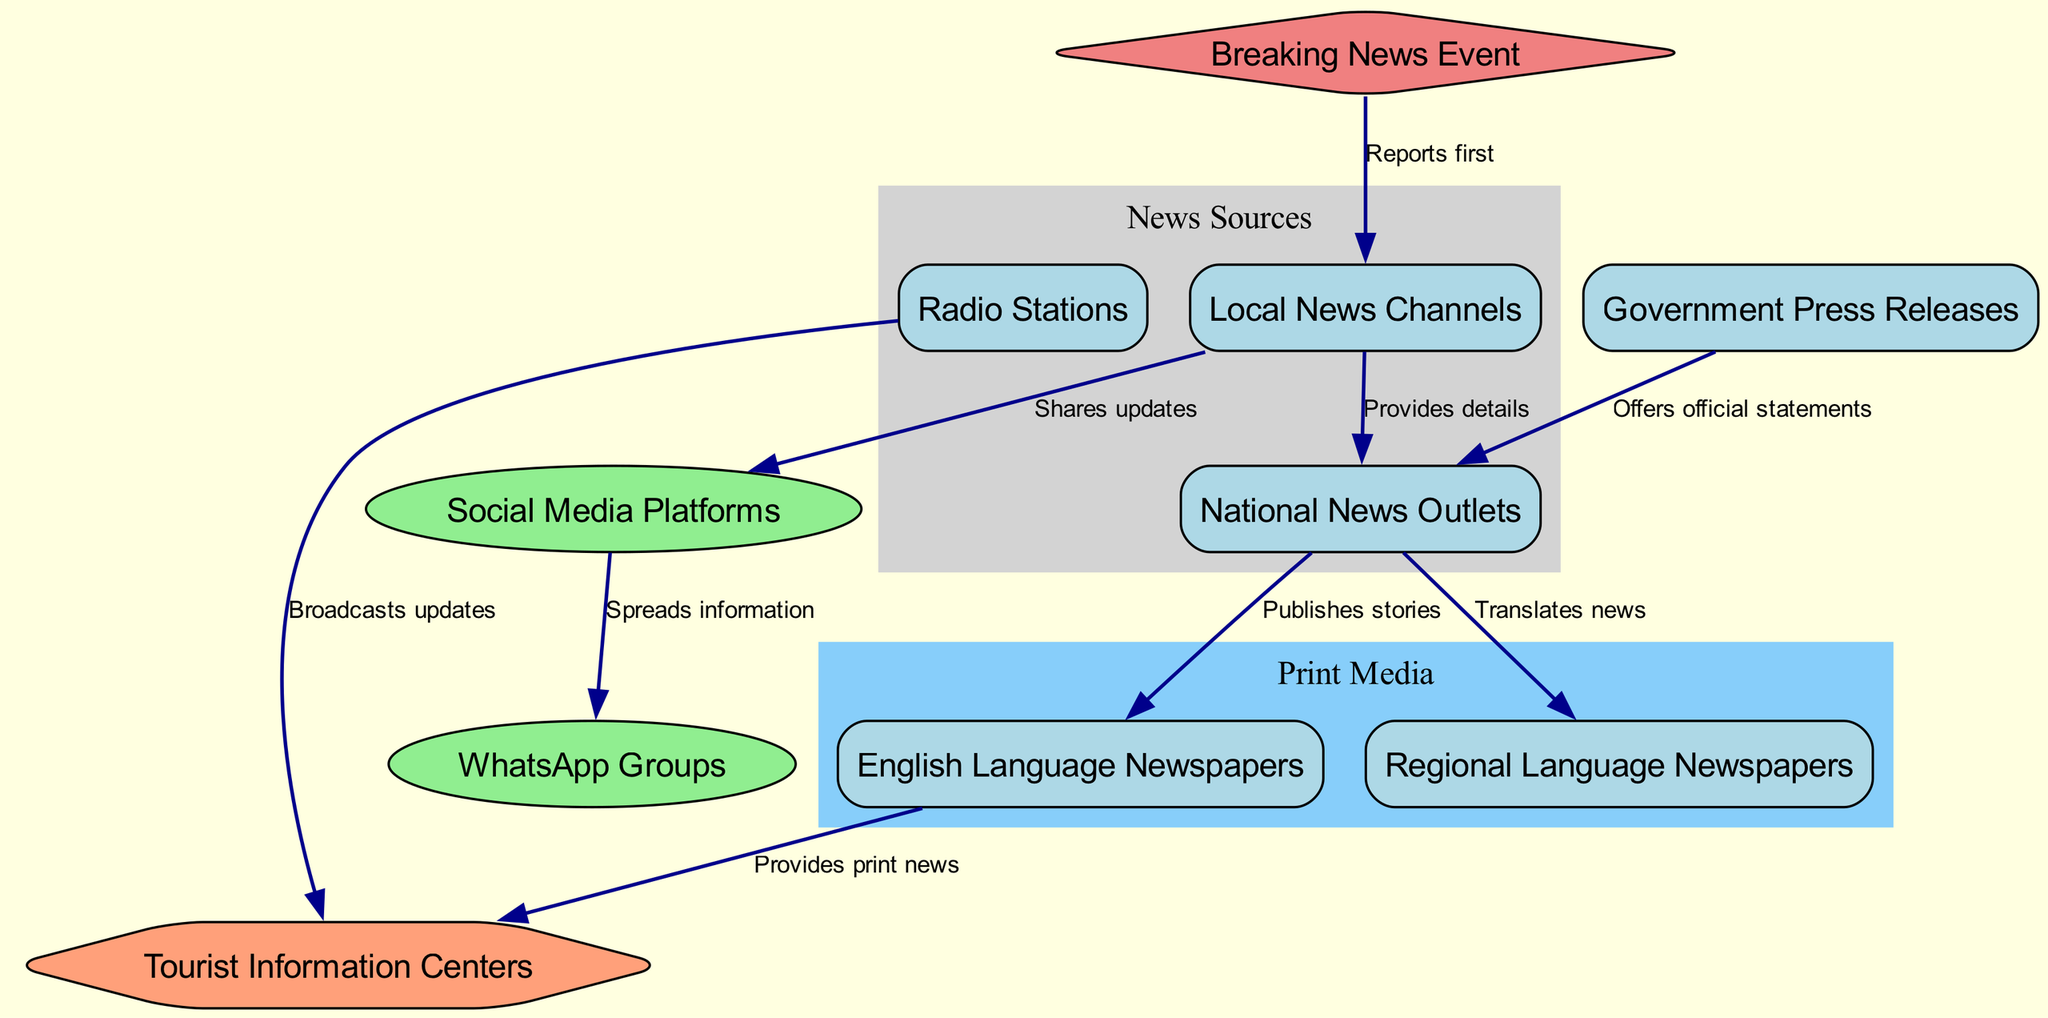What is the first source to report a breaking news event? The diagram indicates that the "Local News Channels" node is the first source to receive information from the "Breaking News Event" node, as shown by the directed edge.
Answer: Local News Channels How many nodes are in the diagram? By counting all the distinct entities listed as nodes, there are ten nodes shown in the diagram representing different media and information sources.
Answer: 10 What type of media shares updates after local news channels? According to the diagram, "Social Media Platforms" share updates post the "Local News Channels." This is indicated by a directed edge leading from Local News Channels to Social Media Platforms.
Answer: Social Media Platforms Which type of newspapers receives translated news from national news outlets? The edge from "National News Outlets" to "Regional Language Newspapers" indicates that these newspapers receive information that is translated, confirming that the newspapers involved are regional in language.
Answer: Regional Language Newspapers What is the role of government press releases in the information dissemination process? The directed edge from "Government Press Releases" to "National News Outlets" shows that they offer official statements, indicating their crucial role in providing verified information to larger news outlets.
Answer: Offers official statements Which information source is connected to both radio stations and tourist information centers? The diagram shows a connection from "Radio Stations" to "Tourist Information Centers" through a directed edge, demonstrating a flow of broadcast updates that ultimately reach the tourist centers.
Answer: Broadcasts updates What is the relationship between social media platforms and WhatsApp groups? The directed edge from "Social Media Platforms" to "WhatsApp Groups" indicates that social media spreads information, which is then shared within WhatsApp groups, implying a flow of communication from one to the other.
Answer: Spreads information Which media type publishes stories based on national news outlets? The directed edge pointing from "National News Outlets" to "English Language Newspapers" indicates that the newspapers take information and publish stories derived from the national coverage of events.
Answer: Publishes stories How do local news channels influence national news outlets? The edge leading from "Local News Channels" to "National News Outlets" demonstrates that local channels provide detailed information, thus impacting the national level coverage and news elaboration.
Answer: Provides details 